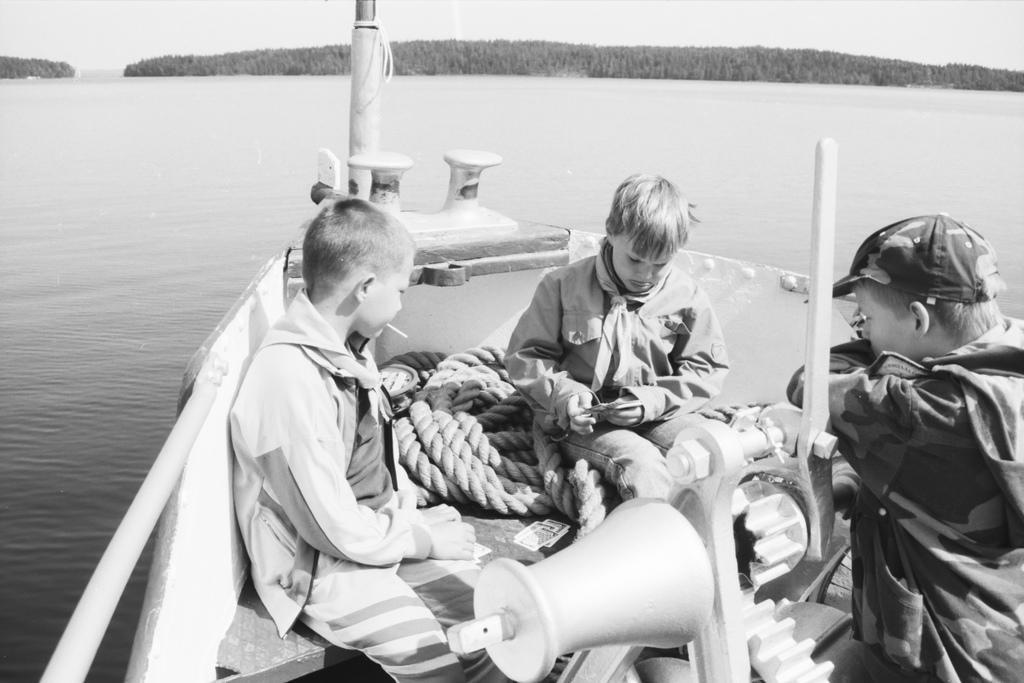Can you describe this image briefly? In this image I can see water and in it I can see a boat. I can also see a rope and few children over here. I can see this image is black and white in colour. 